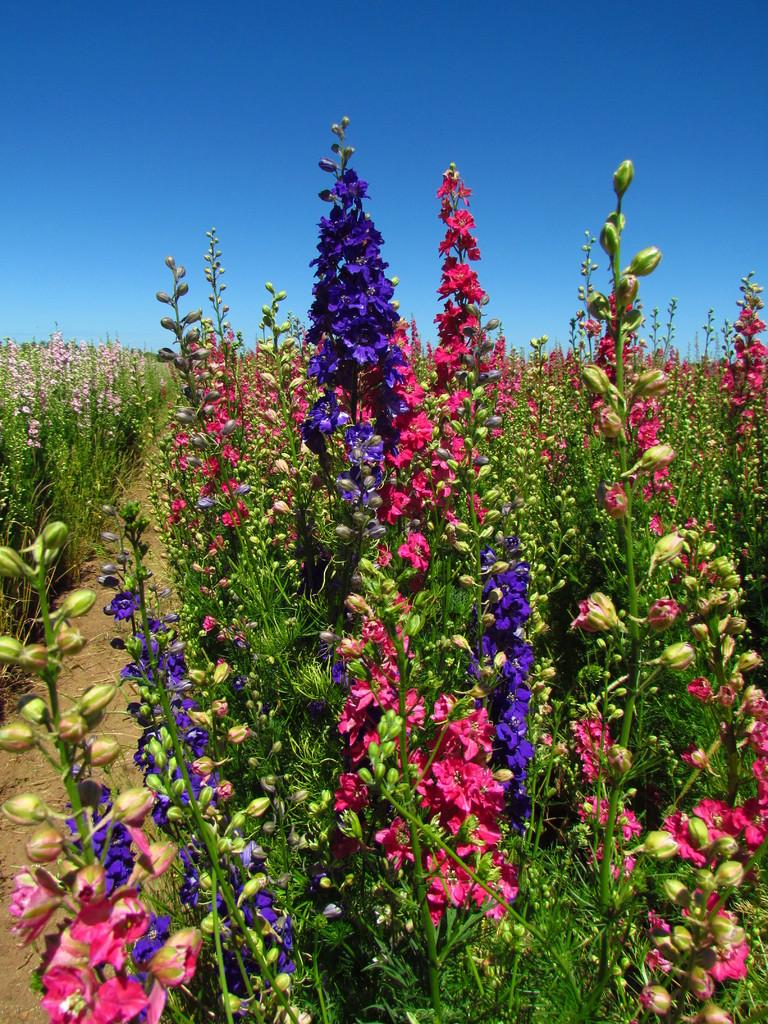What type of living organisms can be seen in the image? Plants and flowers can be seen in the image. What stage of growth can be observed in the image? There are buds in the image, indicating that some of the plants are in the early stages of growth. What is visible in the background of the image? The sky is visible in the background of the image. What is the color of the sky in the image? The color of the sky is blue. How many spiders are crawling on the flowers in the image? There are no spiders present in the image; it features plants and flowers. What type of jail can be seen in the image? There is no jail present in the image. 